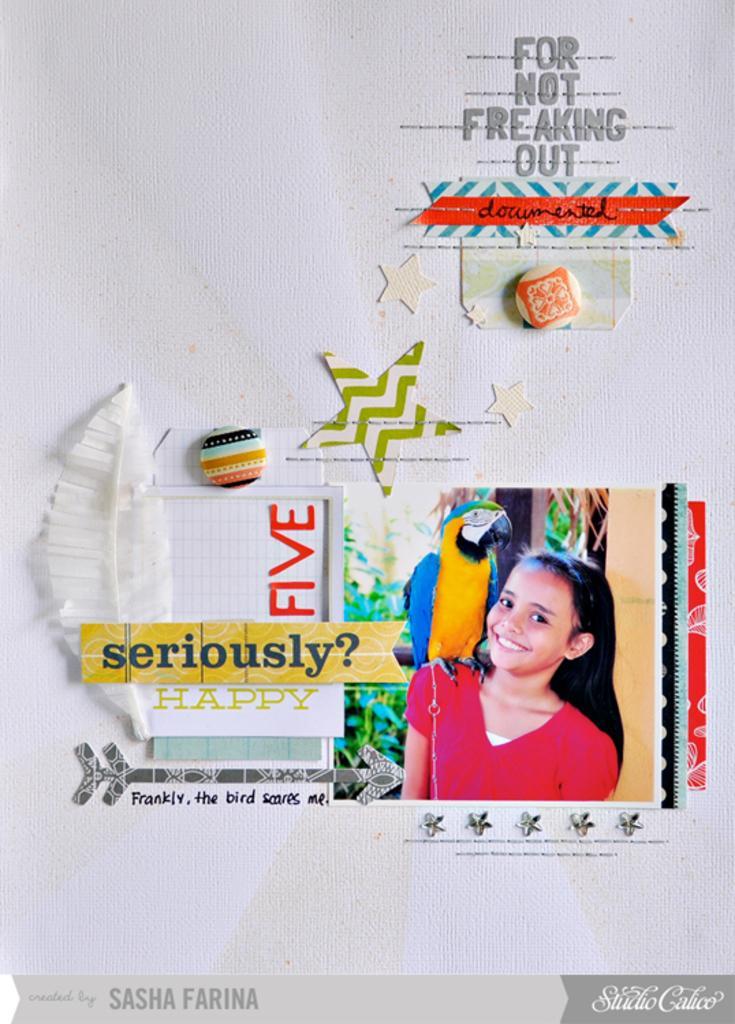Could you give a brief overview of what you see in this image? There are some stickers and posters are attached to a white color wall as we can see in the middle of this image. We can see there is a picture of a girl and a parrot at the bottom of this image. 